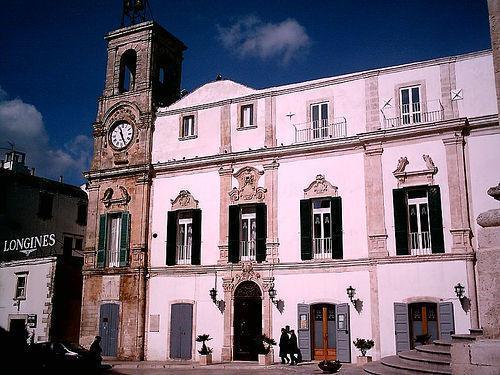How many clocks are there?
Give a very brief answer. 1. How many stories are below the clock?
Give a very brief answer. 2. 